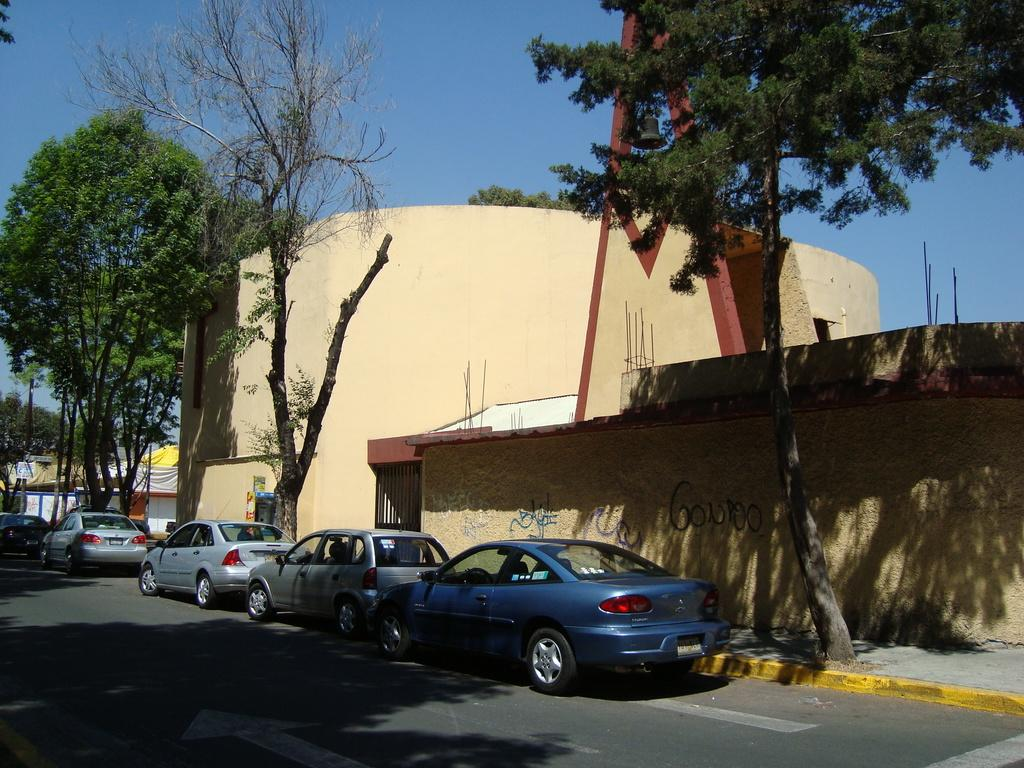What type of vehicles can be seen on the road in the image? There are cars on the road in the image. What structures are visible in the image? There are buildings in the image. What type of vegetation is present in the image? There are trees in the image. What are the rods used for in the image? The purpose of the rods in the image is not specified, but they are visible. What other objects can be seen in the image? There are other objects in the image, but their specific details are not mentioned. What can be seen in the background of the image? The sky is visible in the background of the image. How many kittens are playing with the engine in the image? There are no kittens or engines present in the image. What achievements has the achiever accomplished in the image? There is no achiever or any achievements mentioned in the image. 